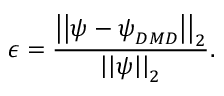Convert formula to latex. <formula><loc_0><loc_0><loc_500><loc_500>\epsilon = \frac { \left | \left | \psi - \psi _ { D M D } \right | \right | _ { 2 } } { \left | \left | \psi \right | \right | _ { 2 } } .</formula> 